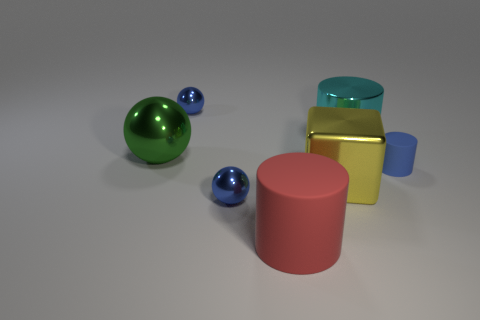Subtract all green spheres. How many spheres are left? 2 Subtract all gray cylinders. How many blue balls are left? 2 Subtract 1 cylinders. How many cylinders are left? 2 Add 1 tiny purple metal blocks. How many objects exist? 8 Subtract 1 red cylinders. How many objects are left? 6 Subtract all cylinders. How many objects are left? 4 Subtract all yellow metallic objects. Subtract all large cyan shiny objects. How many objects are left? 5 Add 3 small blue spheres. How many small blue spheres are left? 5 Add 4 big metal objects. How many big metal objects exist? 7 